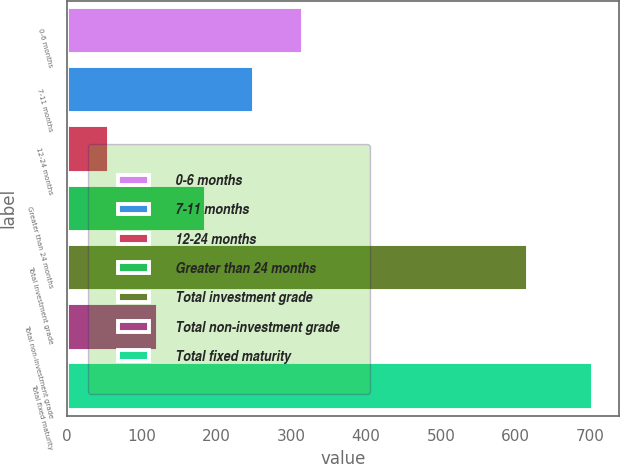<chart> <loc_0><loc_0><loc_500><loc_500><bar_chart><fcel>0-6 months<fcel>7-11 months<fcel>12-24 months<fcel>Greater than 24 months<fcel>Total investment grade<fcel>Total non-investment grade<fcel>Total fixed maturity<nl><fcel>315.4<fcel>250.8<fcel>57<fcel>186.2<fcel>616<fcel>121.6<fcel>703<nl></chart> 